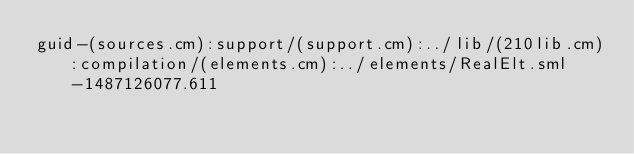<code> <loc_0><loc_0><loc_500><loc_500><_SML_>guid-(sources.cm):support/(support.cm):../lib/(210lib.cm):compilation/(elements.cm):../elements/RealElt.sml-1487126077.611
</code> 